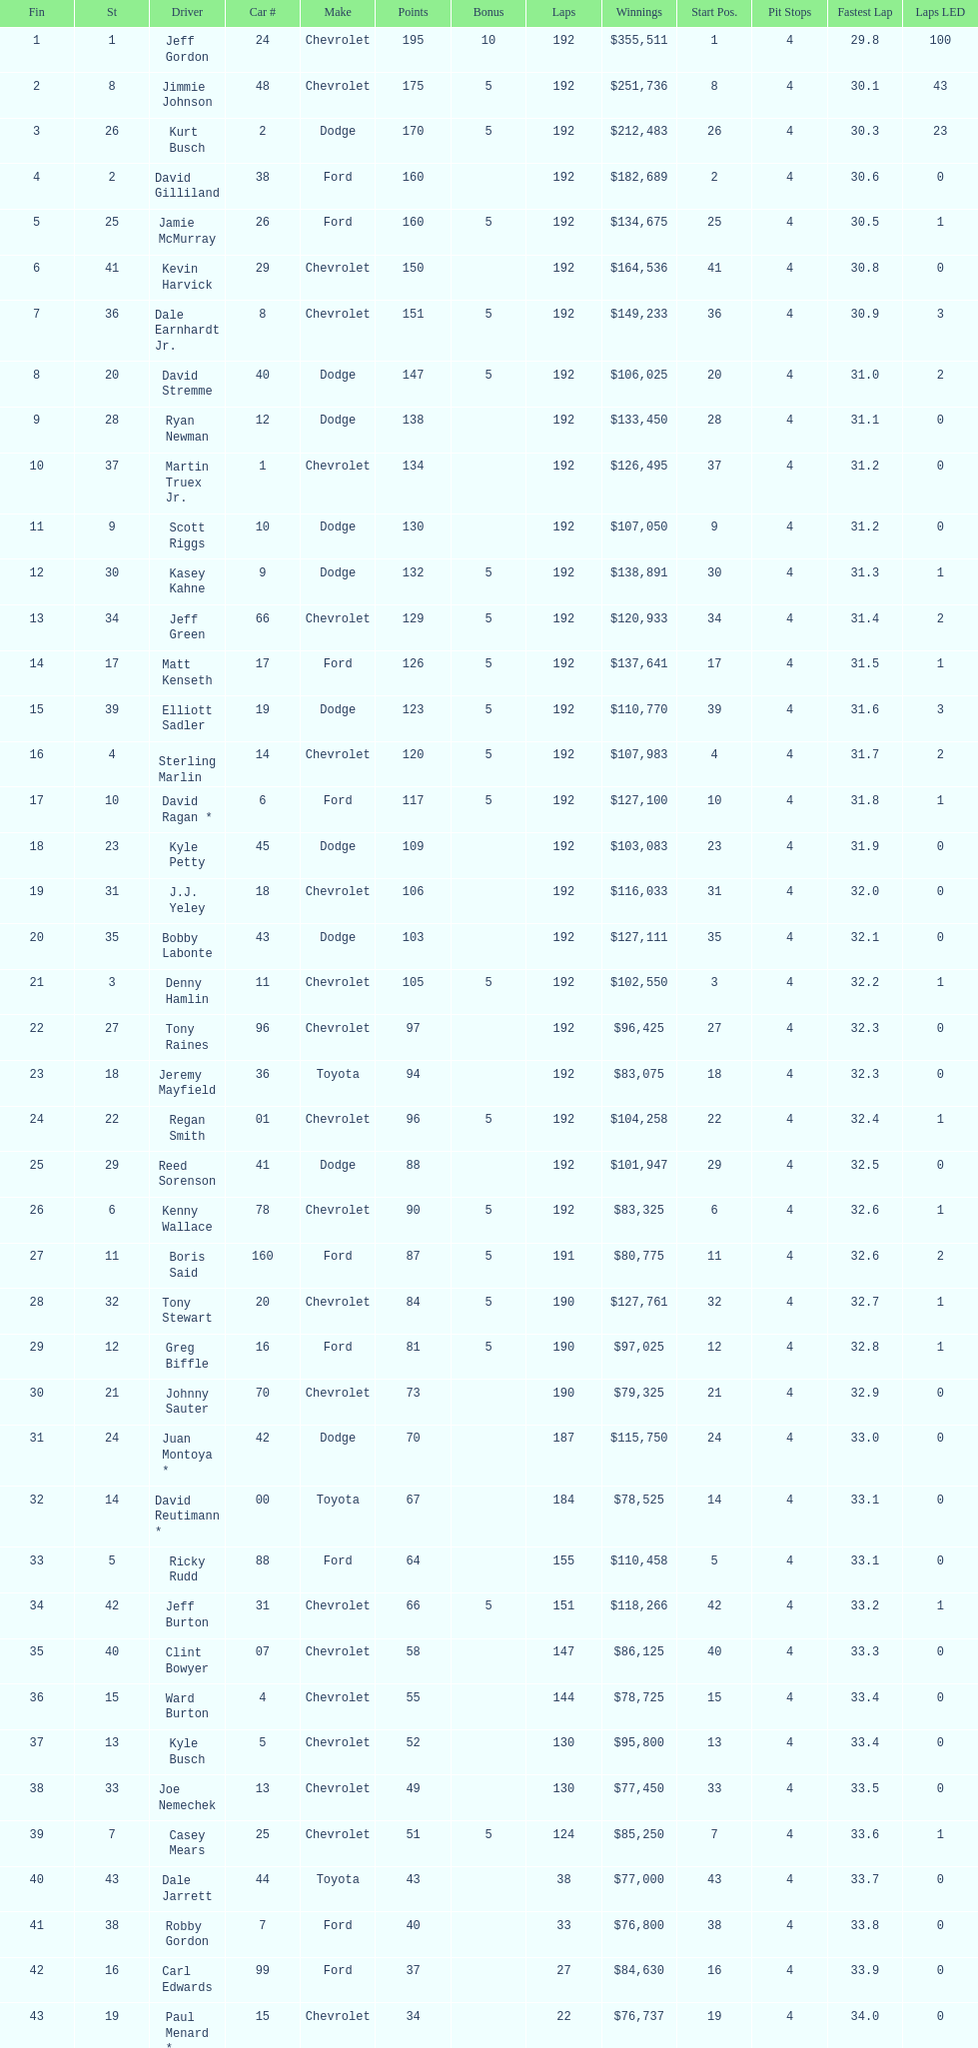Which make had the most consecutive finishes at the aarons 499? Chevrolet. 